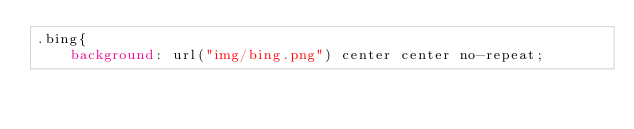<code> <loc_0><loc_0><loc_500><loc_500><_CSS_>.bing{
	background: url("img/bing.png") center center no-repeat;</code> 